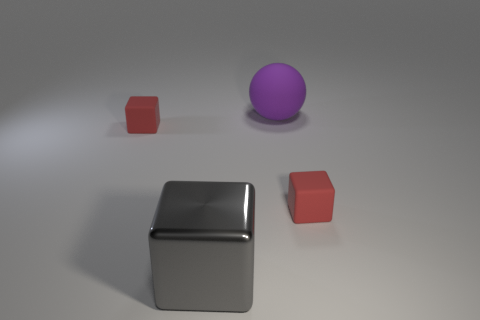Subtract all small red matte blocks. How many blocks are left? 1 Subtract all gray blocks. How many blocks are left? 2 Subtract 1 cubes. How many cubes are left? 2 Subtract all balls. How many objects are left? 3 Add 4 big yellow shiny cylinders. How many objects exist? 8 Subtract 0 blue cylinders. How many objects are left? 4 Subtract all cyan cubes. Subtract all red cylinders. How many cubes are left? 3 Subtract all green cylinders. How many gray blocks are left? 1 Subtract all large gray cubes. Subtract all tiny red rubber blocks. How many objects are left? 1 Add 4 small things. How many small things are left? 6 